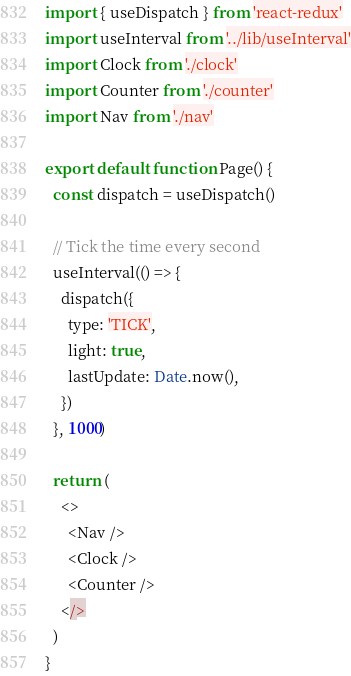Convert code to text. <code><loc_0><loc_0><loc_500><loc_500><_JavaScript_>import { useDispatch } from 'react-redux'
import useInterval from '../lib/useInterval'
import Clock from './clock'
import Counter from './counter'
import Nav from './nav'

export default function Page() {
  const dispatch = useDispatch()

  // Tick the time every second
  useInterval(() => {
    dispatch({
      type: 'TICK',
      light: true,
      lastUpdate: Date.now(),
    })
  }, 1000)

  return (
    <>
      <Nav />
      <Clock />
      <Counter />
    </>
  )
}
</code> 